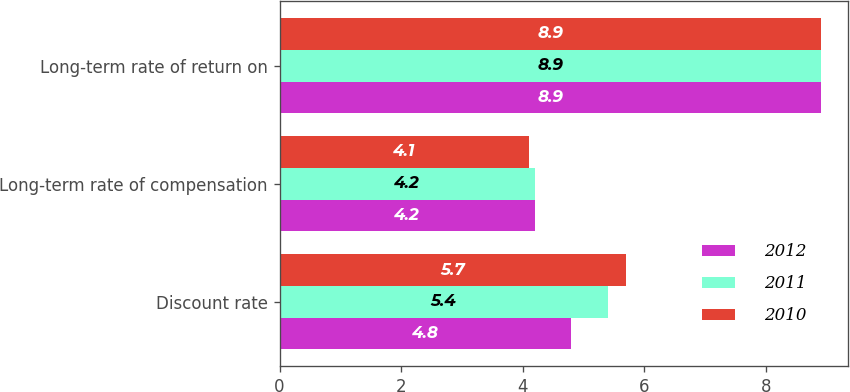Convert chart. <chart><loc_0><loc_0><loc_500><loc_500><stacked_bar_chart><ecel><fcel>Discount rate<fcel>Long-term rate of compensation<fcel>Long-term rate of return on<nl><fcel>2012<fcel>4.8<fcel>4.2<fcel>8.9<nl><fcel>2011<fcel>5.4<fcel>4.2<fcel>8.9<nl><fcel>2010<fcel>5.7<fcel>4.1<fcel>8.9<nl></chart> 